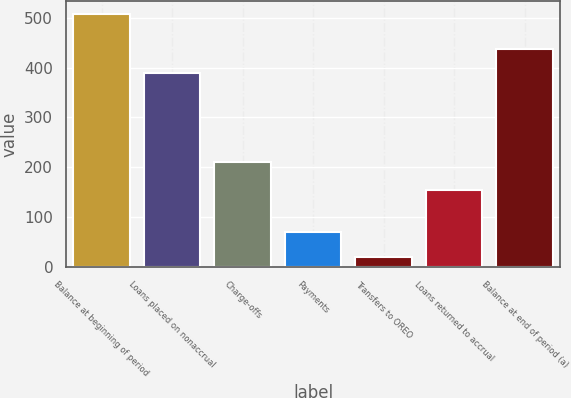<chart> <loc_0><loc_0><loc_500><loc_500><bar_chart><fcel>Balance at beginning of period<fcel>Loans placed on nonaccrual<fcel>Charge-offs<fcel>Payments<fcel>Transfers to OREO<fcel>Loans returned to accrual<fcel>Balance at end of period (a)<nl><fcel>508<fcel>389<fcel>211<fcel>68.8<fcel>20<fcel>154<fcel>437.8<nl></chart> 